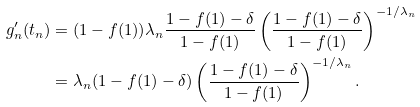<formula> <loc_0><loc_0><loc_500><loc_500>g ^ { \prime } _ { n } ( t _ { n } ) & = ( 1 - f ( 1 ) ) \lambda _ { n } \frac { 1 - f ( 1 ) - \delta } { 1 - f ( 1 ) } \left ( \frac { 1 - f ( 1 ) - \delta } { 1 - f ( 1 ) } \right ) ^ { - 1 / \lambda _ { n } } \\ & = \lambda _ { n } ( 1 - f ( 1 ) - \delta ) \left ( \frac { 1 - f ( 1 ) - \delta } { 1 - f ( 1 ) } \right ) ^ { - 1 / \lambda _ { n } } .</formula> 